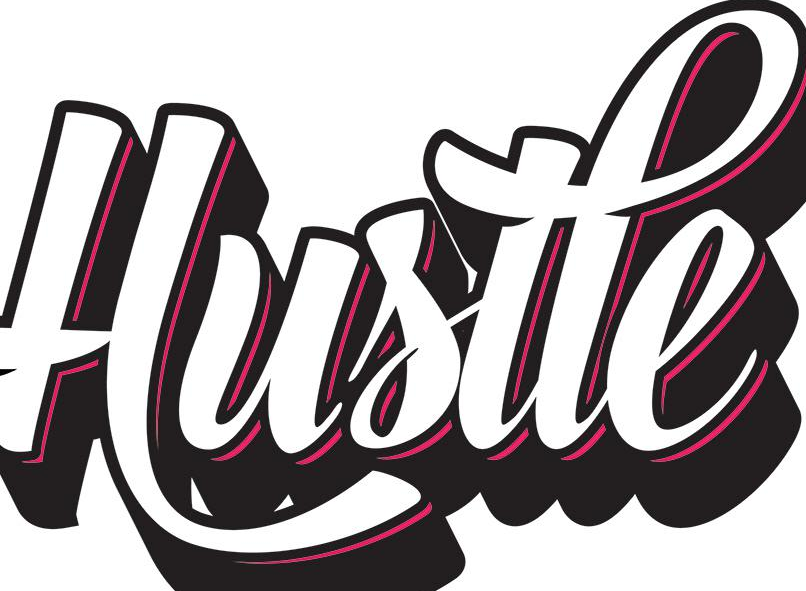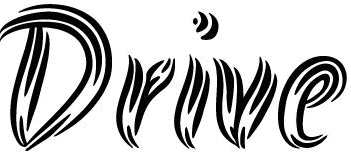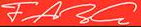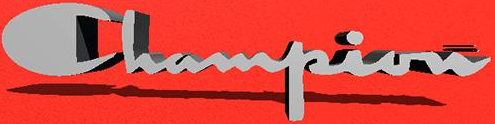Read the text from these images in sequence, separated by a semicolon. Hustle; Drive; FARG; Champion 